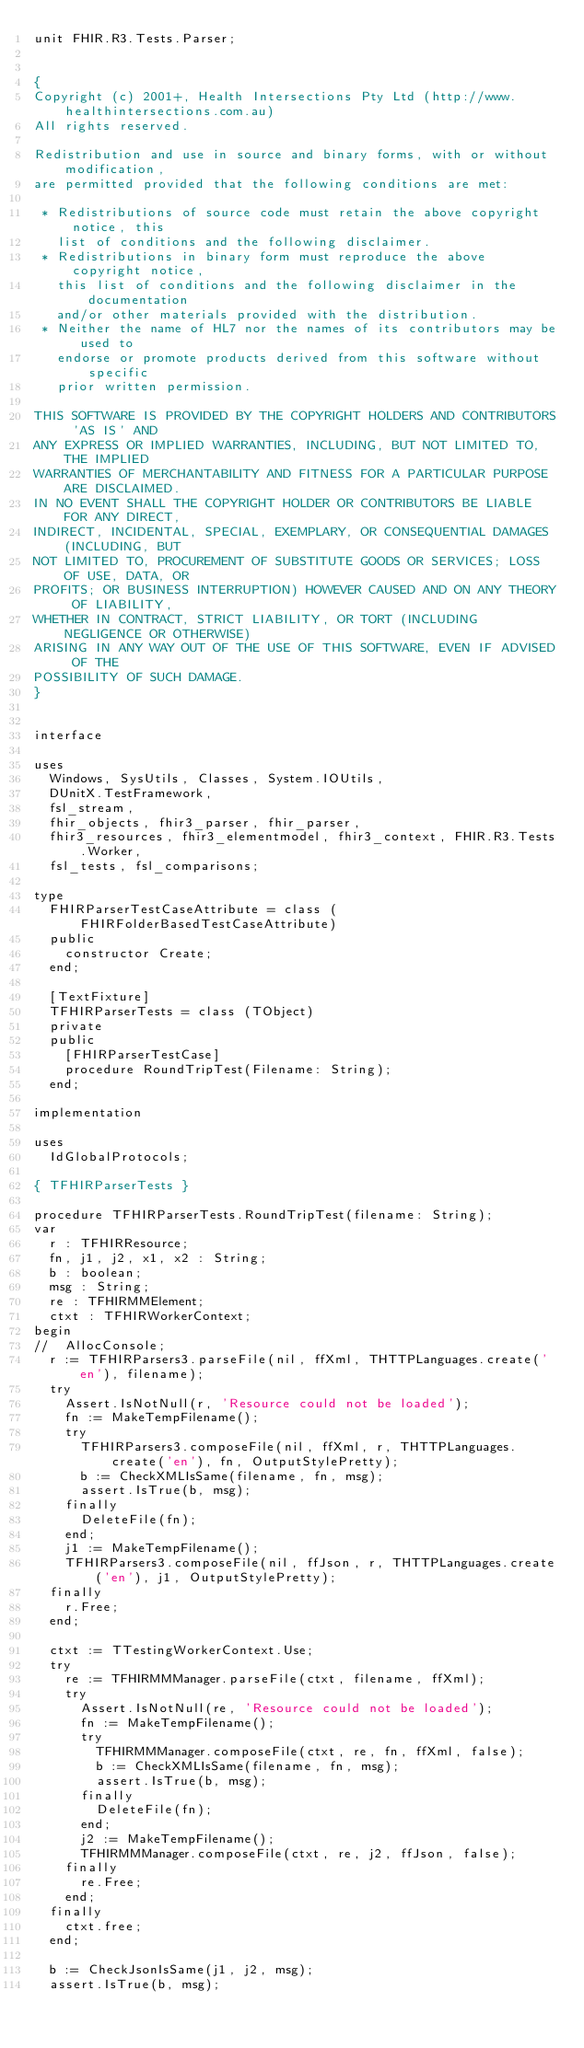Convert code to text. <code><loc_0><loc_0><loc_500><loc_500><_Pascal_>unit FHIR.R3.Tests.Parser;


{
Copyright (c) 2001+, Health Intersections Pty Ltd (http://www.healthintersections.com.au)
All rights reserved.

Redistribution and use in source and binary forms, with or without modification,
are permitted provided that the following conditions are met:

 * Redistributions of source code must retain the above copyright notice, this
   list of conditions and the following disclaimer.
 * Redistributions in binary form must reproduce the above copyright notice,
   this list of conditions and the following disclaimer in the documentation
   and/or other materials provided with the distribution.
 * Neither the name of HL7 nor the names of its contributors may be used to
   endorse or promote products derived from this software without specific
   prior written permission.

THIS SOFTWARE IS PROVIDED BY THE COPYRIGHT HOLDERS AND CONTRIBUTORS 'AS IS' AND
ANY EXPRESS OR IMPLIED WARRANTIES, INCLUDING, BUT NOT LIMITED TO, THE IMPLIED
WARRANTIES OF MERCHANTABILITY AND FITNESS FOR A PARTICULAR PURPOSE ARE DISCLAIMED.
IN NO EVENT SHALL THE COPYRIGHT HOLDER OR CONTRIBUTORS BE LIABLE FOR ANY DIRECT,
INDIRECT, INCIDENTAL, SPECIAL, EXEMPLARY, OR CONSEQUENTIAL DAMAGES (INCLUDING, BUT
NOT LIMITED TO, PROCUREMENT OF SUBSTITUTE GOODS OR SERVICES; LOSS OF USE, DATA, OR
PROFITS; OR BUSINESS INTERRUPTION) HOWEVER CAUSED AND ON ANY THEORY OF LIABILITY,
WHETHER IN CONTRACT, STRICT LIABILITY, OR TORT (INCLUDING NEGLIGENCE OR OTHERWISE)
ARISING IN ANY WAY OUT OF THE USE OF THIS SOFTWARE, EVEN IF ADVISED OF THE
POSSIBILITY OF SUCH DAMAGE.
}


interface

uses
  Windows, SysUtils, Classes, System.IOUtils,
  DUnitX.TestFramework,
  fsl_stream,
  fhir_objects, fhir3_parser, fhir_parser,
  fhir3_resources, fhir3_elementmodel, fhir3_context, FHIR.R3.Tests.Worker,
  fsl_tests, fsl_comparisons;

type
  FHIRParserTestCaseAttribute = class (FHIRFolderBasedTestCaseAttribute)
  public
    constructor Create;
  end;

  [TextFixture]
  TFHIRParserTests = class (TObject)
  private
  public
    [FHIRParserTestCase]
    procedure RoundTripTest(Filename: String);
  end;

implementation

uses
  IdGlobalProtocols;

{ TFHIRParserTests }

procedure TFHIRParserTests.RoundTripTest(filename: String);
var
  r : TFHIRResource;
  fn, j1, j2, x1, x2 : String;
  b : boolean;
  msg : String;
  re : TFHIRMMElement;
  ctxt : TFHIRWorkerContext;
begin
//  AllocConsole;
  r := TFHIRParsers3.parseFile(nil, ffXml, THTTPLanguages.create('en'), filename);
  try
    Assert.IsNotNull(r, 'Resource could not be loaded');
    fn := MakeTempFilename();
    try
      TFHIRParsers3.composeFile(nil, ffXml, r, THTTPLanguages.create('en'), fn, OutputStylePretty);
      b := CheckXMLIsSame(filename, fn, msg);
      assert.IsTrue(b, msg);
    finally
      DeleteFile(fn);
    end;
    j1 := MakeTempFilename();
    TFHIRParsers3.composeFile(nil, ffJson, r, THTTPLanguages.create('en'), j1, OutputStylePretty);
  finally
    r.Free;
  end;

  ctxt := TTestingWorkerContext.Use;
  try
    re := TFHIRMMManager.parseFile(ctxt, filename, ffXml);
    try
      Assert.IsNotNull(re, 'Resource could not be loaded');
      fn := MakeTempFilename();
      try
        TFHIRMMManager.composeFile(ctxt, re, fn, ffXml, false);
        b := CheckXMLIsSame(filename, fn, msg);
        assert.IsTrue(b, msg);
      finally
        DeleteFile(fn);
      end;
      j2 := MakeTempFilename();
      TFHIRMMManager.composeFile(ctxt, re, j2, ffJson, false);
    finally
      re.Free;
    end;
  finally
    ctxt.free;
  end;

  b := CheckJsonIsSame(j1, j2, msg);
  assert.IsTrue(b, msg);
</code> 